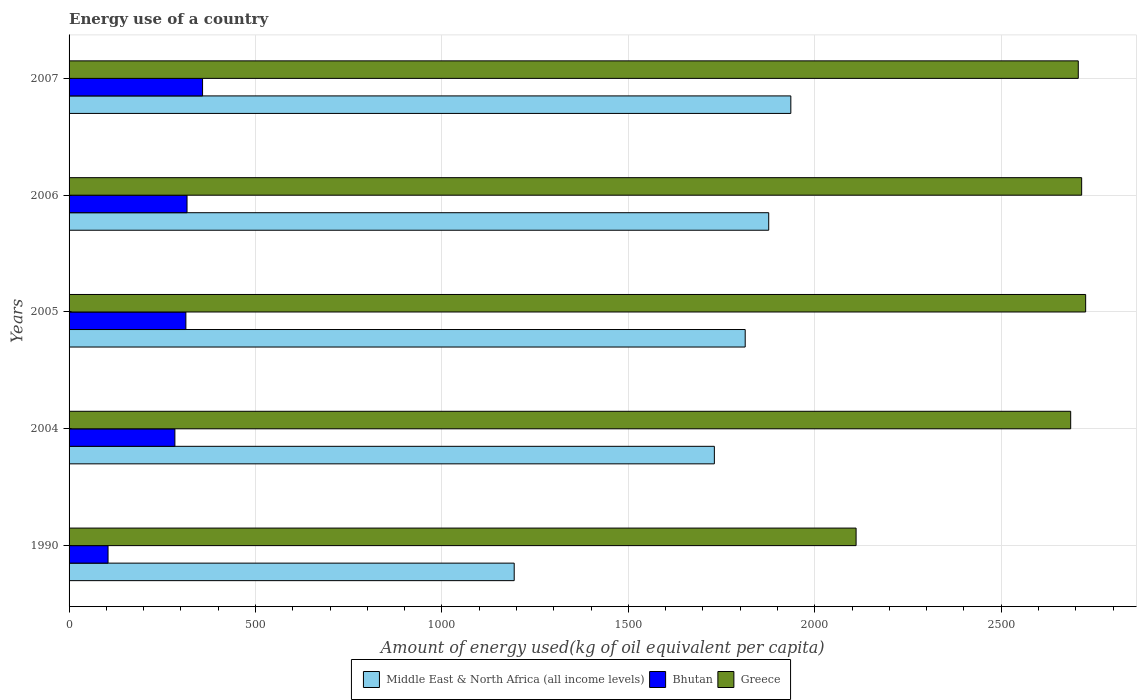Are the number of bars on each tick of the Y-axis equal?
Keep it short and to the point. Yes. How many bars are there on the 1st tick from the top?
Give a very brief answer. 3. What is the amount of energy used in in Middle East & North Africa (all income levels) in 2007?
Your answer should be very brief. 1935.88. Across all years, what is the maximum amount of energy used in in Greece?
Your response must be concise. 2726.67. Across all years, what is the minimum amount of energy used in in Middle East & North Africa (all income levels)?
Provide a short and direct response. 1193.94. In which year was the amount of energy used in in Middle East & North Africa (all income levels) maximum?
Your answer should be very brief. 2007. What is the total amount of energy used in in Bhutan in the graph?
Give a very brief answer. 1376.05. What is the difference between the amount of energy used in in Bhutan in 2004 and that in 2005?
Your answer should be compact. -29.48. What is the difference between the amount of energy used in in Middle East & North Africa (all income levels) in 2004 and the amount of energy used in in Greece in 2005?
Offer a very short reply. -995.89. What is the average amount of energy used in in Middle East & North Africa (all income levels) per year?
Offer a terse response. 1710.13. In the year 2004, what is the difference between the amount of energy used in in Bhutan and amount of energy used in in Middle East & North Africa (all income levels)?
Ensure brevity in your answer.  -1446.97. In how many years, is the amount of energy used in in Greece greater than 2300 kg?
Your answer should be very brief. 4. What is the ratio of the amount of energy used in in Middle East & North Africa (all income levels) in 1990 to that in 2004?
Your response must be concise. 0.69. Is the amount of energy used in in Greece in 2004 less than that in 2007?
Ensure brevity in your answer.  Yes. Is the difference between the amount of energy used in in Bhutan in 2005 and 2007 greater than the difference between the amount of energy used in in Middle East & North Africa (all income levels) in 2005 and 2007?
Your response must be concise. Yes. What is the difference between the highest and the second highest amount of energy used in in Greece?
Ensure brevity in your answer.  10.74. What is the difference between the highest and the lowest amount of energy used in in Greece?
Offer a terse response. 615.73. In how many years, is the amount of energy used in in Bhutan greater than the average amount of energy used in in Bhutan taken over all years?
Keep it short and to the point. 4. Is the sum of the amount of energy used in in Middle East & North Africa (all income levels) in 2004 and 2005 greater than the maximum amount of energy used in in Greece across all years?
Offer a very short reply. Yes. What does the 2nd bar from the top in 2004 represents?
Provide a succinct answer. Bhutan. What does the 3rd bar from the bottom in 2004 represents?
Your response must be concise. Greece. Are the values on the major ticks of X-axis written in scientific E-notation?
Give a very brief answer. No. Does the graph contain any zero values?
Your answer should be very brief. No. Does the graph contain grids?
Ensure brevity in your answer.  Yes. How are the legend labels stacked?
Your answer should be very brief. Horizontal. What is the title of the graph?
Give a very brief answer. Energy use of a country. What is the label or title of the X-axis?
Provide a succinct answer. Amount of energy used(kg of oil equivalent per capita). What is the Amount of energy used(kg of oil equivalent per capita) of Middle East & North Africa (all income levels) in 1990?
Your answer should be compact. 1193.94. What is the Amount of energy used(kg of oil equivalent per capita) in Bhutan in 1990?
Offer a terse response. 104.53. What is the Amount of energy used(kg of oil equivalent per capita) of Greece in 1990?
Offer a terse response. 2110.94. What is the Amount of energy used(kg of oil equivalent per capita) of Middle East & North Africa (all income levels) in 2004?
Give a very brief answer. 1730.78. What is the Amount of energy used(kg of oil equivalent per capita) of Bhutan in 2004?
Offer a very short reply. 283.81. What is the Amount of energy used(kg of oil equivalent per capita) of Greece in 2004?
Provide a short and direct response. 2686.52. What is the Amount of energy used(kg of oil equivalent per capita) in Middle East & North Africa (all income levels) in 2005?
Your answer should be very brief. 1813.5. What is the Amount of energy used(kg of oil equivalent per capita) of Bhutan in 2005?
Provide a short and direct response. 313.29. What is the Amount of energy used(kg of oil equivalent per capita) of Greece in 2005?
Provide a succinct answer. 2726.67. What is the Amount of energy used(kg of oil equivalent per capita) of Middle East & North Africa (all income levels) in 2006?
Provide a short and direct response. 1876.56. What is the Amount of energy used(kg of oil equivalent per capita) in Bhutan in 2006?
Make the answer very short. 316.38. What is the Amount of energy used(kg of oil equivalent per capita) in Greece in 2006?
Ensure brevity in your answer.  2715.93. What is the Amount of energy used(kg of oil equivalent per capita) of Middle East & North Africa (all income levels) in 2007?
Keep it short and to the point. 1935.88. What is the Amount of energy used(kg of oil equivalent per capita) of Bhutan in 2007?
Offer a very short reply. 358.05. What is the Amount of energy used(kg of oil equivalent per capita) of Greece in 2007?
Ensure brevity in your answer.  2706.86. Across all years, what is the maximum Amount of energy used(kg of oil equivalent per capita) of Middle East & North Africa (all income levels)?
Give a very brief answer. 1935.88. Across all years, what is the maximum Amount of energy used(kg of oil equivalent per capita) in Bhutan?
Your answer should be compact. 358.05. Across all years, what is the maximum Amount of energy used(kg of oil equivalent per capita) of Greece?
Make the answer very short. 2726.67. Across all years, what is the minimum Amount of energy used(kg of oil equivalent per capita) of Middle East & North Africa (all income levels)?
Your answer should be very brief. 1193.94. Across all years, what is the minimum Amount of energy used(kg of oil equivalent per capita) of Bhutan?
Your response must be concise. 104.53. Across all years, what is the minimum Amount of energy used(kg of oil equivalent per capita) in Greece?
Your response must be concise. 2110.94. What is the total Amount of energy used(kg of oil equivalent per capita) in Middle East & North Africa (all income levels) in the graph?
Offer a terse response. 8550.66. What is the total Amount of energy used(kg of oil equivalent per capita) in Bhutan in the graph?
Make the answer very short. 1376.05. What is the total Amount of energy used(kg of oil equivalent per capita) in Greece in the graph?
Your response must be concise. 1.29e+04. What is the difference between the Amount of energy used(kg of oil equivalent per capita) in Middle East & North Africa (all income levels) in 1990 and that in 2004?
Ensure brevity in your answer.  -536.84. What is the difference between the Amount of energy used(kg of oil equivalent per capita) in Bhutan in 1990 and that in 2004?
Keep it short and to the point. -179.28. What is the difference between the Amount of energy used(kg of oil equivalent per capita) in Greece in 1990 and that in 2004?
Provide a short and direct response. -575.58. What is the difference between the Amount of energy used(kg of oil equivalent per capita) of Middle East & North Africa (all income levels) in 1990 and that in 2005?
Offer a terse response. -619.57. What is the difference between the Amount of energy used(kg of oil equivalent per capita) of Bhutan in 1990 and that in 2005?
Keep it short and to the point. -208.76. What is the difference between the Amount of energy used(kg of oil equivalent per capita) in Greece in 1990 and that in 2005?
Offer a terse response. -615.73. What is the difference between the Amount of energy used(kg of oil equivalent per capita) of Middle East & North Africa (all income levels) in 1990 and that in 2006?
Provide a succinct answer. -682.62. What is the difference between the Amount of energy used(kg of oil equivalent per capita) in Bhutan in 1990 and that in 2006?
Offer a very short reply. -211.85. What is the difference between the Amount of energy used(kg of oil equivalent per capita) in Greece in 1990 and that in 2006?
Offer a very short reply. -604.99. What is the difference between the Amount of energy used(kg of oil equivalent per capita) of Middle East & North Africa (all income levels) in 1990 and that in 2007?
Keep it short and to the point. -741.94. What is the difference between the Amount of energy used(kg of oil equivalent per capita) in Bhutan in 1990 and that in 2007?
Your response must be concise. -253.52. What is the difference between the Amount of energy used(kg of oil equivalent per capita) of Greece in 1990 and that in 2007?
Your answer should be compact. -595.92. What is the difference between the Amount of energy used(kg of oil equivalent per capita) of Middle East & North Africa (all income levels) in 2004 and that in 2005?
Keep it short and to the point. -82.73. What is the difference between the Amount of energy used(kg of oil equivalent per capita) of Bhutan in 2004 and that in 2005?
Offer a terse response. -29.48. What is the difference between the Amount of energy used(kg of oil equivalent per capita) of Greece in 2004 and that in 2005?
Provide a succinct answer. -40.15. What is the difference between the Amount of energy used(kg of oil equivalent per capita) of Middle East & North Africa (all income levels) in 2004 and that in 2006?
Ensure brevity in your answer.  -145.79. What is the difference between the Amount of energy used(kg of oil equivalent per capita) in Bhutan in 2004 and that in 2006?
Provide a succinct answer. -32.57. What is the difference between the Amount of energy used(kg of oil equivalent per capita) in Greece in 2004 and that in 2006?
Your answer should be very brief. -29.41. What is the difference between the Amount of energy used(kg of oil equivalent per capita) in Middle East & North Africa (all income levels) in 2004 and that in 2007?
Give a very brief answer. -205.1. What is the difference between the Amount of energy used(kg of oil equivalent per capita) in Bhutan in 2004 and that in 2007?
Ensure brevity in your answer.  -74.24. What is the difference between the Amount of energy used(kg of oil equivalent per capita) of Greece in 2004 and that in 2007?
Give a very brief answer. -20.34. What is the difference between the Amount of energy used(kg of oil equivalent per capita) in Middle East & North Africa (all income levels) in 2005 and that in 2006?
Keep it short and to the point. -63.06. What is the difference between the Amount of energy used(kg of oil equivalent per capita) of Bhutan in 2005 and that in 2006?
Your response must be concise. -3.09. What is the difference between the Amount of energy used(kg of oil equivalent per capita) in Greece in 2005 and that in 2006?
Give a very brief answer. 10.74. What is the difference between the Amount of energy used(kg of oil equivalent per capita) in Middle East & North Africa (all income levels) in 2005 and that in 2007?
Your answer should be very brief. -122.37. What is the difference between the Amount of energy used(kg of oil equivalent per capita) of Bhutan in 2005 and that in 2007?
Ensure brevity in your answer.  -44.76. What is the difference between the Amount of energy used(kg of oil equivalent per capita) of Greece in 2005 and that in 2007?
Give a very brief answer. 19.81. What is the difference between the Amount of energy used(kg of oil equivalent per capita) in Middle East & North Africa (all income levels) in 2006 and that in 2007?
Provide a succinct answer. -59.31. What is the difference between the Amount of energy used(kg of oil equivalent per capita) in Bhutan in 2006 and that in 2007?
Offer a terse response. -41.67. What is the difference between the Amount of energy used(kg of oil equivalent per capita) in Greece in 2006 and that in 2007?
Make the answer very short. 9.07. What is the difference between the Amount of energy used(kg of oil equivalent per capita) of Middle East & North Africa (all income levels) in 1990 and the Amount of energy used(kg of oil equivalent per capita) of Bhutan in 2004?
Your response must be concise. 910.13. What is the difference between the Amount of energy used(kg of oil equivalent per capita) of Middle East & North Africa (all income levels) in 1990 and the Amount of energy used(kg of oil equivalent per capita) of Greece in 2004?
Keep it short and to the point. -1492.58. What is the difference between the Amount of energy used(kg of oil equivalent per capita) in Bhutan in 1990 and the Amount of energy used(kg of oil equivalent per capita) in Greece in 2004?
Your response must be concise. -2581.99. What is the difference between the Amount of energy used(kg of oil equivalent per capita) of Middle East & North Africa (all income levels) in 1990 and the Amount of energy used(kg of oil equivalent per capita) of Bhutan in 2005?
Give a very brief answer. 880.65. What is the difference between the Amount of energy used(kg of oil equivalent per capita) in Middle East & North Africa (all income levels) in 1990 and the Amount of energy used(kg of oil equivalent per capita) in Greece in 2005?
Your response must be concise. -1532.73. What is the difference between the Amount of energy used(kg of oil equivalent per capita) of Bhutan in 1990 and the Amount of energy used(kg of oil equivalent per capita) of Greece in 2005?
Your answer should be compact. -2622.14. What is the difference between the Amount of energy used(kg of oil equivalent per capita) of Middle East & North Africa (all income levels) in 1990 and the Amount of energy used(kg of oil equivalent per capita) of Bhutan in 2006?
Your answer should be very brief. 877.56. What is the difference between the Amount of energy used(kg of oil equivalent per capita) of Middle East & North Africa (all income levels) in 1990 and the Amount of energy used(kg of oil equivalent per capita) of Greece in 2006?
Offer a very short reply. -1521.99. What is the difference between the Amount of energy used(kg of oil equivalent per capita) of Bhutan in 1990 and the Amount of energy used(kg of oil equivalent per capita) of Greece in 2006?
Your answer should be very brief. -2611.4. What is the difference between the Amount of energy used(kg of oil equivalent per capita) of Middle East & North Africa (all income levels) in 1990 and the Amount of energy used(kg of oil equivalent per capita) of Bhutan in 2007?
Offer a very short reply. 835.89. What is the difference between the Amount of energy used(kg of oil equivalent per capita) of Middle East & North Africa (all income levels) in 1990 and the Amount of energy used(kg of oil equivalent per capita) of Greece in 2007?
Ensure brevity in your answer.  -1512.92. What is the difference between the Amount of energy used(kg of oil equivalent per capita) in Bhutan in 1990 and the Amount of energy used(kg of oil equivalent per capita) in Greece in 2007?
Your answer should be compact. -2602.33. What is the difference between the Amount of energy used(kg of oil equivalent per capita) in Middle East & North Africa (all income levels) in 2004 and the Amount of energy used(kg of oil equivalent per capita) in Bhutan in 2005?
Make the answer very short. 1417.49. What is the difference between the Amount of energy used(kg of oil equivalent per capita) of Middle East & North Africa (all income levels) in 2004 and the Amount of energy used(kg of oil equivalent per capita) of Greece in 2005?
Provide a succinct answer. -995.89. What is the difference between the Amount of energy used(kg of oil equivalent per capita) in Bhutan in 2004 and the Amount of energy used(kg of oil equivalent per capita) in Greece in 2005?
Provide a short and direct response. -2442.86. What is the difference between the Amount of energy used(kg of oil equivalent per capita) in Middle East & North Africa (all income levels) in 2004 and the Amount of energy used(kg of oil equivalent per capita) in Bhutan in 2006?
Keep it short and to the point. 1414.4. What is the difference between the Amount of energy used(kg of oil equivalent per capita) in Middle East & North Africa (all income levels) in 2004 and the Amount of energy used(kg of oil equivalent per capita) in Greece in 2006?
Ensure brevity in your answer.  -985.15. What is the difference between the Amount of energy used(kg of oil equivalent per capita) of Bhutan in 2004 and the Amount of energy used(kg of oil equivalent per capita) of Greece in 2006?
Offer a very short reply. -2432.12. What is the difference between the Amount of energy used(kg of oil equivalent per capita) of Middle East & North Africa (all income levels) in 2004 and the Amount of energy used(kg of oil equivalent per capita) of Bhutan in 2007?
Make the answer very short. 1372.73. What is the difference between the Amount of energy used(kg of oil equivalent per capita) in Middle East & North Africa (all income levels) in 2004 and the Amount of energy used(kg of oil equivalent per capita) in Greece in 2007?
Your answer should be compact. -976.08. What is the difference between the Amount of energy used(kg of oil equivalent per capita) of Bhutan in 2004 and the Amount of energy used(kg of oil equivalent per capita) of Greece in 2007?
Offer a very short reply. -2423.05. What is the difference between the Amount of energy used(kg of oil equivalent per capita) in Middle East & North Africa (all income levels) in 2005 and the Amount of energy used(kg of oil equivalent per capita) in Bhutan in 2006?
Your answer should be compact. 1497.12. What is the difference between the Amount of energy used(kg of oil equivalent per capita) in Middle East & North Africa (all income levels) in 2005 and the Amount of energy used(kg of oil equivalent per capita) in Greece in 2006?
Give a very brief answer. -902.43. What is the difference between the Amount of energy used(kg of oil equivalent per capita) of Bhutan in 2005 and the Amount of energy used(kg of oil equivalent per capita) of Greece in 2006?
Your response must be concise. -2402.64. What is the difference between the Amount of energy used(kg of oil equivalent per capita) of Middle East & North Africa (all income levels) in 2005 and the Amount of energy used(kg of oil equivalent per capita) of Bhutan in 2007?
Offer a terse response. 1455.46. What is the difference between the Amount of energy used(kg of oil equivalent per capita) of Middle East & North Africa (all income levels) in 2005 and the Amount of energy used(kg of oil equivalent per capita) of Greece in 2007?
Offer a terse response. -893.36. What is the difference between the Amount of energy used(kg of oil equivalent per capita) in Bhutan in 2005 and the Amount of energy used(kg of oil equivalent per capita) in Greece in 2007?
Ensure brevity in your answer.  -2393.57. What is the difference between the Amount of energy used(kg of oil equivalent per capita) of Middle East & North Africa (all income levels) in 2006 and the Amount of energy used(kg of oil equivalent per capita) of Bhutan in 2007?
Your answer should be very brief. 1518.51. What is the difference between the Amount of energy used(kg of oil equivalent per capita) of Middle East & North Africa (all income levels) in 2006 and the Amount of energy used(kg of oil equivalent per capita) of Greece in 2007?
Your answer should be very brief. -830.3. What is the difference between the Amount of energy used(kg of oil equivalent per capita) of Bhutan in 2006 and the Amount of energy used(kg of oil equivalent per capita) of Greece in 2007?
Keep it short and to the point. -2390.48. What is the average Amount of energy used(kg of oil equivalent per capita) of Middle East & North Africa (all income levels) per year?
Keep it short and to the point. 1710.13. What is the average Amount of energy used(kg of oil equivalent per capita) in Bhutan per year?
Your answer should be compact. 275.21. What is the average Amount of energy used(kg of oil equivalent per capita) of Greece per year?
Your response must be concise. 2589.38. In the year 1990, what is the difference between the Amount of energy used(kg of oil equivalent per capita) in Middle East & North Africa (all income levels) and Amount of energy used(kg of oil equivalent per capita) in Bhutan?
Offer a terse response. 1089.41. In the year 1990, what is the difference between the Amount of energy used(kg of oil equivalent per capita) of Middle East & North Africa (all income levels) and Amount of energy used(kg of oil equivalent per capita) of Greece?
Offer a very short reply. -917. In the year 1990, what is the difference between the Amount of energy used(kg of oil equivalent per capita) of Bhutan and Amount of energy used(kg of oil equivalent per capita) of Greece?
Your answer should be very brief. -2006.41. In the year 2004, what is the difference between the Amount of energy used(kg of oil equivalent per capita) of Middle East & North Africa (all income levels) and Amount of energy used(kg of oil equivalent per capita) of Bhutan?
Make the answer very short. 1446.97. In the year 2004, what is the difference between the Amount of energy used(kg of oil equivalent per capita) in Middle East & North Africa (all income levels) and Amount of energy used(kg of oil equivalent per capita) in Greece?
Offer a very short reply. -955.74. In the year 2004, what is the difference between the Amount of energy used(kg of oil equivalent per capita) of Bhutan and Amount of energy used(kg of oil equivalent per capita) of Greece?
Give a very brief answer. -2402.71. In the year 2005, what is the difference between the Amount of energy used(kg of oil equivalent per capita) in Middle East & North Africa (all income levels) and Amount of energy used(kg of oil equivalent per capita) in Bhutan?
Keep it short and to the point. 1500.22. In the year 2005, what is the difference between the Amount of energy used(kg of oil equivalent per capita) of Middle East & North Africa (all income levels) and Amount of energy used(kg of oil equivalent per capita) of Greece?
Your answer should be very brief. -913.16. In the year 2005, what is the difference between the Amount of energy used(kg of oil equivalent per capita) in Bhutan and Amount of energy used(kg of oil equivalent per capita) in Greece?
Give a very brief answer. -2413.38. In the year 2006, what is the difference between the Amount of energy used(kg of oil equivalent per capita) in Middle East & North Africa (all income levels) and Amount of energy used(kg of oil equivalent per capita) in Bhutan?
Provide a succinct answer. 1560.18. In the year 2006, what is the difference between the Amount of energy used(kg of oil equivalent per capita) in Middle East & North Africa (all income levels) and Amount of energy used(kg of oil equivalent per capita) in Greece?
Offer a very short reply. -839.37. In the year 2006, what is the difference between the Amount of energy used(kg of oil equivalent per capita) of Bhutan and Amount of energy used(kg of oil equivalent per capita) of Greece?
Offer a very short reply. -2399.55. In the year 2007, what is the difference between the Amount of energy used(kg of oil equivalent per capita) in Middle East & North Africa (all income levels) and Amount of energy used(kg of oil equivalent per capita) in Bhutan?
Keep it short and to the point. 1577.83. In the year 2007, what is the difference between the Amount of energy used(kg of oil equivalent per capita) in Middle East & North Africa (all income levels) and Amount of energy used(kg of oil equivalent per capita) in Greece?
Your response must be concise. -770.99. In the year 2007, what is the difference between the Amount of energy used(kg of oil equivalent per capita) of Bhutan and Amount of energy used(kg of oil equivalent per capita) of Greece?
Provide a succinct answer. -2348.81. What is the ratio of the Amount of energy used(kg of oil equivalent per capita) of Middle East & North Africa (all income levels) in 1990 to that in 2004?
Make the answer very short. 0.69. What is the ratio of the Amount of energy used(kg of oil equivalent per capita) of Bhutan in 1990 to that in 2004?
Give a very brief answer. 0.37. What is the ratio of the Amount of energy used(kg of oil equivalent per capita) in Greece in 1990 to that in 2004?
Offer a terse response. 0.79. What is the ratio of the Amount of energy used(kg of oil equivalent per capita) in Middle East & North Africa (all income levels) in 1990 to that in 2005?
Provide a succinct answer. 0.66. What is the ratio of the Amount of energy used(kg of oil equivalent per capita) of Bhutan in 1990 to that in 2005?
Your answer should be very brief. 0.33. What is the ratio of the Amount of energy used(kg of oil equivalent per capita) in Greece in 1990 to that in 2005?
Your response must be concise. 0.77. What is the ratio of the Amount of energy used(kg of oil equivalent per capita) in Middle East & North Africa (all income levels) in 1990 to that in 2006?
Provide a succinct answer. 0.64. What is the ratio of the Amount of energy used(kg of oil equivalent per capita) of Bhutan in 1990 to that in 2006?
Give a very brief answer. 0.33. What is the ratio of the Amount of energy used(kg of oil equivalent per capita) of Greece in 1990 to that in 2006?
Give a very brief answer. 0.78. What is the ratio of the Amount of energy used(kg of oil equivalent per capita) of Middle East & North Africa (all income levels) in 1990 to that in 2007?
Make the answer very short. 0.62. What is the ratio of the Amount of energy used(kg of oil equivalent per capita) of Bhutan in 1990 to that in 2007?
Your answer should be very brief. 0.29. What is the ratio of the Amount of energy used(kg of oil equivalent per capita) in Greece in 1990 to that in 2007?
Your answer should be very brief. 0.78. What is the ratio of the Amount of energy used(kg of oil equivalent per capita) of Middle East & North Africa (all income levels) in 2004 to that in 2005?
Your answer should be very brief. 0.95. What is the ratio of the Amount of energy used(kg of oil equivalent per capita) of Bhutan in 2004 to that in 2005?
Your answer should be compact. 0.91. What is the ratio of the Amount of energy used(kg of oil equivalent per capita) in Middle East & North Africa (all income levels) in 2004 to that in 2006?
Your answer should be very brief. 0.92. What is the ratio of the Amount of energy used(kg of oil equivalent per capita) in Bhutan in 2004 to that in 2006?
Provide a succinct answer. 0.9. What is the ratio of the Amount of energy used(kg of oil equivalent per capita) of Greece in 2004 to that in 2006?
Ensure brevity in your answer.  0.99. What is the ratio of the Amount of energy used(kg of oil equivalent per capita) of Middle East & North Africa (all income levels) in 2004 to that in 2007?
Your response must be concise. 0.89. What is the ratio of the Amount of energy used(kg of oil equivalent per capita) of Bhutan in 2004 to that in 2007?
Provide a short and direct response. 0.79. What is the ratio of the Amount of energy used(kg of oil equivalent per capita) in Greece in 2004 to that in 2007?
Keep it short and to the point. 0.99. What is the ratio of the Amount of energy used(kg of oil equivalent per capita) in Middle East & North Africa (all income levels) in 2005 to that in 2006?
Keep it short and to the point. 0.97. What is the ratio of the Amount of energy used(kg of oil equivalent per capita) of Bhutan in 2005 to that in 2006?
Offer a terse response. 0.99. What is the ratio of the Amount of energy used(kg of oil equivalent per capita) in Greece in 2005 to that in 2006?
Offer a very short reply. 1. What is the ratio of the Amount of energy used(kg of oil equivalent per capita) in Middle East & North Africa (all income levels) in 2005 to that in 2007?
Offer a terse response. 0.94. What is the ratio of the Amount of energy used(kg of oil equivalent per capita) in Greece in 2005 to that in 2007?
Offer a terse response. 1.01. What is the ratio of the Amount of energy used(kg of oil equivalent per capita) of Middle East & North Africa (all income levels) in 2006 to that in 2007?
Offer a terse response. 0.97. What is the ratio of the Amount of energy used(kg of oil equivalent per capita) in Bhutan in 2006 to that in 2007?
Your response must be concise. 0.88. What is the difference between the highest and the second highest Amount of energy used(kg of oil equivalent per capita) in Middle East & North Africa (all income levels)?
Provide a short and direct response. 59.31. What is the difference between the highest and the second highest Amount of energy used(kg of oil equivalent per capita) of Bhutan?
Provide a short and direct response. 41.67. What is the difference between the highest and the second highest Amount of energy used(kg of oil equivalent per capita) in Greece?
Offer a terse response. 10.74. What is the difference between the highest and the lowest Amount of energy used(kg of oil equivalent per capita) of Middle East & North Africa (all income levels)?
Your answer should be compact. 741.94. What is the difference between the highest and the lowest Amount of energy used(kg of oil equivalent per capita) in Bhutan?
Provide a succinct answer. 253.52. What is the difference between the highest and the lowest Amount of energy used(kg of oil equivalent per capita) in Greece?
Provide a succinct answer. 615.73. 